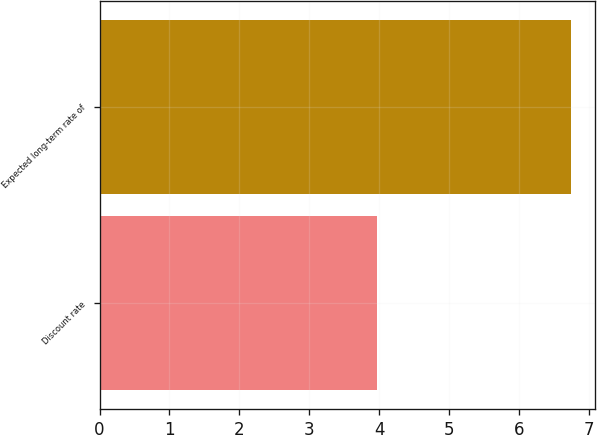<chart> <loc_0><loc_0><loc_500><loc_500><bar_chart><fcel>Discount rate<fcel>Expected long-term rate of<nl><fcel>3.97<fcel>6.75<nl></chart> 